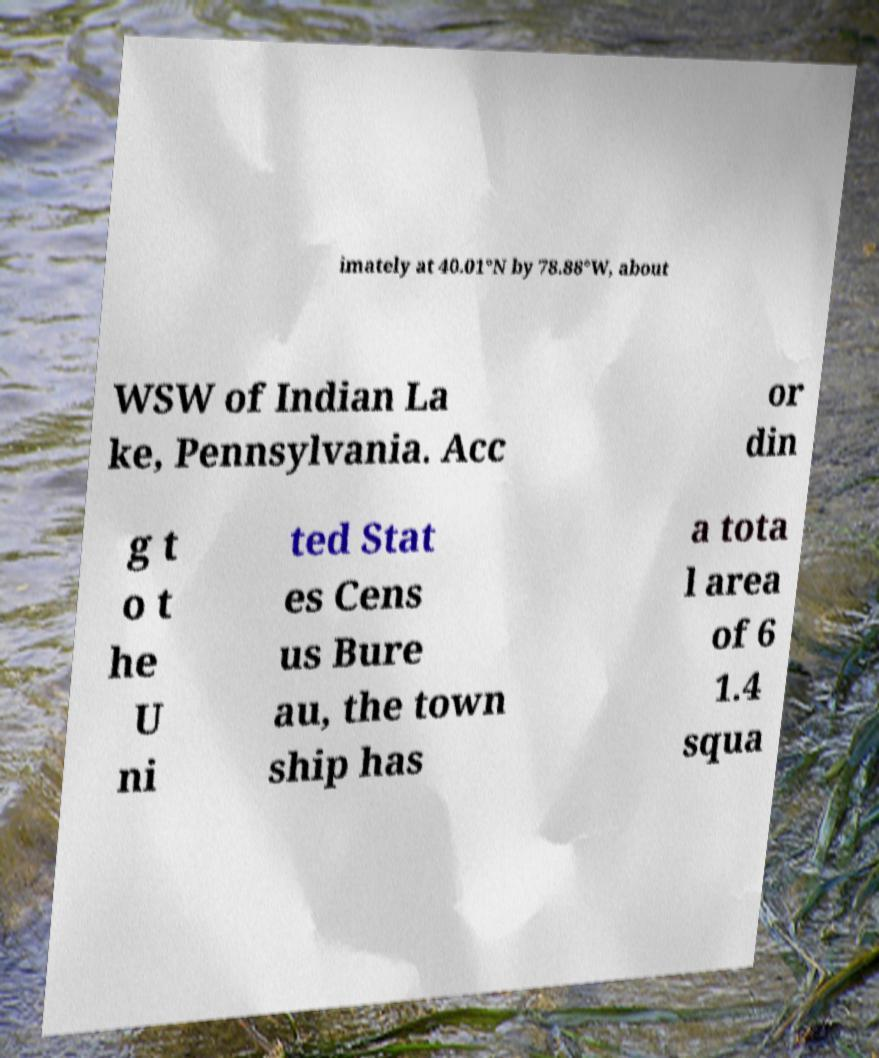Could you extract and type out the text from this image? imately at 40.01°N by 78.88°W, about WSW of Indian La ke, Pennsylvania. Acc or din g t o t he U ni ted Stat es Cens us Bure au, the town ship has a tota l area of 6 1.4 squa 